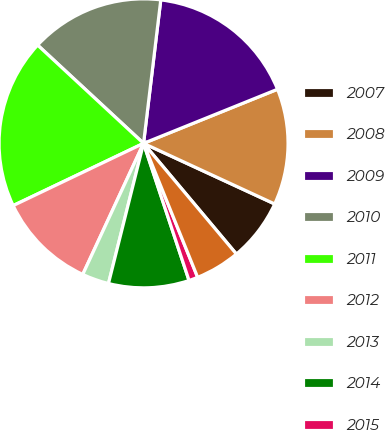<chart> <loc_0><loc_0><loc_500><loc_500><pie_chart><fcel>2007<fcel>2008<fcel>2009<fcel>2010<fcel>2011<fcel>2012<fcel>2013<fcel>2014<fcel>2015<fcel>2016<nl><fcel>7.0%<fcel>13.0%<fcel>16.99%<fcel>15.0%<fcel>18.99%<fcel>11.0%<fcel>3.01%<fcel>9.0%<fcel>1.01%<fcel>5.0%<nl></chart> 